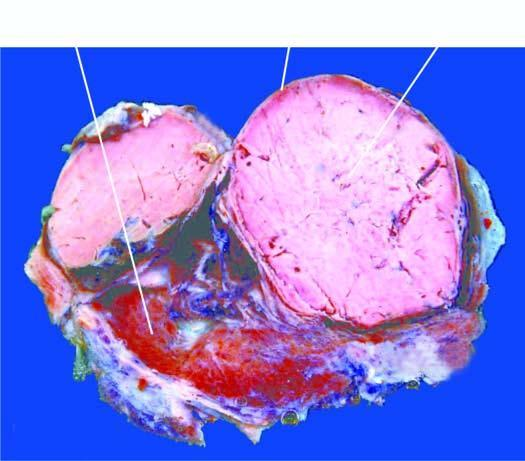does the silicotic nodule show a solitary nodule having capsule?
Answer the question using a single word or phrase. No 